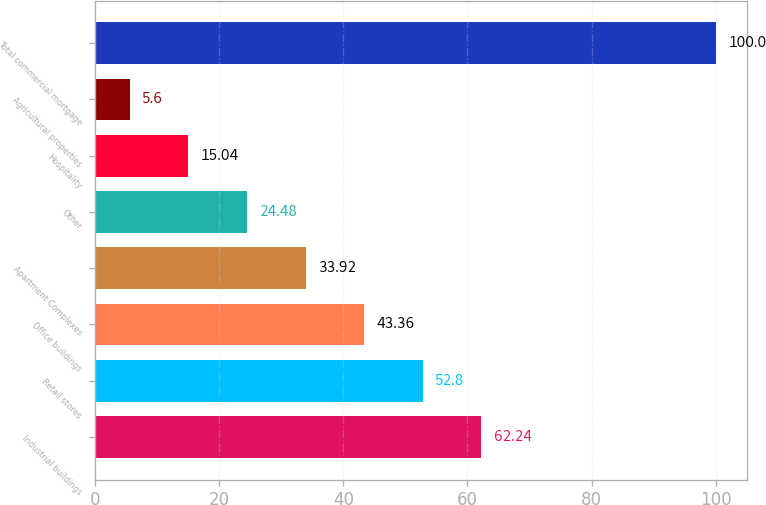<chart> <loc_0><loc_0><loc_500><loc_500><bar_chart><fcel>Industrial buildings<fcel>Retail stores<fcel>Office buildings<fcel>Apartment Complexes<fcel>Other<fcel>Hospitality<fcel>Agricultural properties<fcel>Total commercial mortgage<nl><fcel>62.24<fcel>52.8<fcel>43.36<fcel>33.92<fcel>24.48<fcel>15.04<fcel>5.6<fcel>100<nl></chart> 